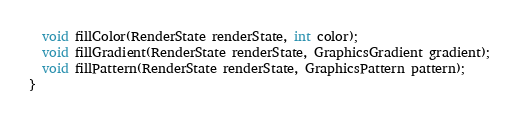Convert code to text. <code><loc_0><loc_0><loc_500><loc_500><_Dart_>  void fillColor(RenderState renderState, int color);
  void fillGradient(RenderState renderState, GraphicsGradient gradient);
  void fillPattern(RenderState renderState, GraphicsPattern pattern);
}
</code> 